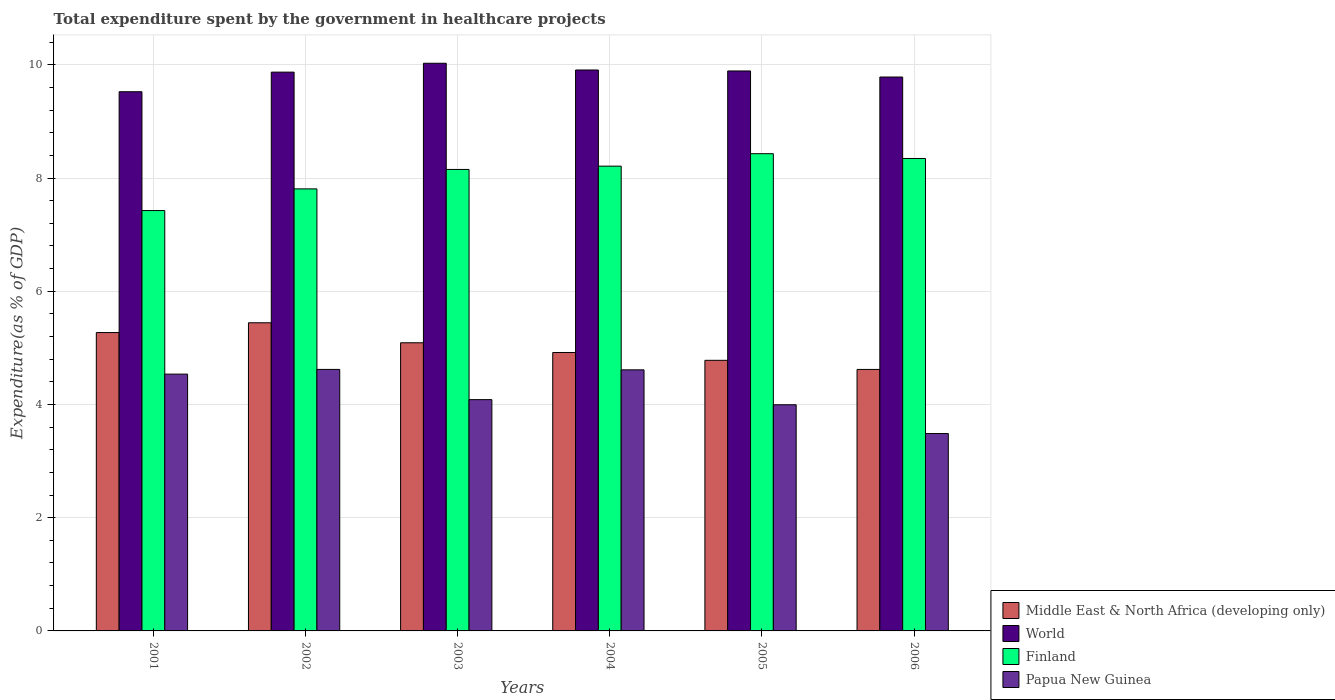How many different coloured bars are there?
Provide a succinct answer. 4. How many bars are there on the 6th tick from the left?
Offer a very short reply. 4. What is the label of the 2nd group of bars from the left?
Provide a succinct answer. 2002. In how many cases, is the number of bars for a given year not equal to the number of legend labels?
Provide a short and direct response. 0. What is the total expenditure spent by the government in healthcare projects in Middle East & North Africa (developing only) in 2006?
Provide a short and direct response. 4.62. Across all years, what is the maximum total expenditure spent by the government in healthcare projects in Finland?
Offer a very short reply. 8.43. Across all years, what is the minimum total expenditure spent by the government in healthcare projects in Papua New Guinea?
Your answer should be compact. 3.49. What is the total total expenditure spent by the government in healthcare projects in World in the graph?
Provide a short and direct response. 59. What is the difference between the total expenditure spent by the government in healthcare projects in Papua New Guinea in 2001 and that in 2003?
Your response must be concise. 0.45. What is the difference between the total expenditure spent by the government in healthcare projects in World in 2005 and the total expenditure spent by the government in healthcare projects in Papua New Guinea in 2006?
Provide a succinct answer. 6.4. What is the average total expenditure spent by the government in healthcare projects in Finland per year?
Provide a short and direct response. 8.06. In the year 2001, what is the difference between the total expenditure spent by the government in healthcare projects in Finland and total expenditure spent by the government in healthcare projects in World?
Offer a terse response. -2.1. What is the ratio of the total expenditure spent by the government in healthcare projects in Papua New Guinea in 2001 to that in 2006?
Ensure brevity in your answer.  1.3. What is the difference between the highest and the second highest total expenditure spent by the government in healthcare projects in World?
Provide a short and direct response. 0.12. What is the difference between the highest and the lowest total expenditure spent by the government in healthcare projects in World?
Provide a succinct answer. 0.5. Is the sum of the total expenditure spent by the government in healthcare projects in Papua New Guinea in 2002 and 2005 greater than the maximum total expenditure spent by the government in healthcare projects in World across all years?
Offer a terse response. No. Is it the case that in every year, the sum of the total expenditure spent by the government in healthcare projects in Middle East & North Africa (developing only) and total expenditure spent by the government in healthcare projects in Papua New Guinea is greater than the sum of total expenditure spent by the government in healthcare projects in Finland and total expenditure spent by the government in healthcare projects in World?
Provide a succinct answer. No. What does the 3rd bar from the left in 2006 represents?
Provide a succinct answer. Finland. What does the 3rd bar from the right in 2005 represents?
Provide a short and direct response. World. How many bars are there?
Offer a very short reply. 24. Are all the bars in the graph horizontal?
Offer a terse response. No. How many years are there in the graph?
Provide a succinct answer. 6. Does the graph contain any zero values?
Offer a very short reply. No. Where does the legend appear in the graph?
Your answer should be compact. Bottom right. How many legend labels are there?
Ensure brevity in your answer.  4. What is the title of the graph?
Give a very brief answer. Total expenditure spent by the government in healthcare projects. Does "Faeroe Islands" appear as one of the legend labels in the graph?
Offer a terse response. No. What is the label or title of the X-axis?
Your answer should be compact. Years. What is the label or title of the Y-axis?
Ensure brevity in your answer.  Expenditure(as % of GDP). What is the Expenditure(as % of GDP) of Middle East & North Africa (developing only) in 2001?
Offer a terse response. 5.27. What is the Expenditure(as % of GDP) in World in 2001?
Offer a very short reply. 9.52. What is the Expenditure(as % of GDP) of Finland in 2001?
Your response must be concise. 7.43. What is the Expenditure(as % of GDP) in Papua New Guinea in 2001?
Ensure brevity in your answer.  4.54. What is the Expenditure(as % of GDP) in Middle East & North Africa (developing only) in 2002?
Offer a very short reply. 5.44. What is the Expenditure(as % of GDP) of World in 2002?
Make the answer very short. 9.87. What is the Expenditure(as % of GDP) of Finland in 2002?
Offer a terse response. 7.81. What is the Expenditure(as % of GDP) of Papua New Guinea in 2002?
Provide a succinct answer. 4.62. What is the Expenditure(as % of GDP) in Middle East & North Africa (developing only) in 2003?
Your response must be concise. 5.09. What is the Expenditure(as % of GDP) of World in 2003?
Your answer should be very brief. 10.03. What is the Expenditure(as % of GDP) of Finland in 2003?
Provide a succinct answer. 8.15. What is the Expenditure(as % of GDP) in Papua New Guinea in 2003?
Offer a very short reply. 4.09. What is the Expenditure(as % of GDP) of Middle East & North Africa (developing only) in 2004?
Give a very brief answer. 4.92. What is the Expenditure(as % of GDP) in World in 2004?
Your answer should be very brief. 9.91. What is the Expenditure(as % of GDP) of Finland in 2004?
Your answer should be very brief. 8.21. What is the Expenditure(as % of GDP) in Papua New Guinea in 2004?
Your answer should be very brief. 4.61. What is the Expenditure(as % of GDP) of Middle East & North Africa (developing only) in 2005?
Provide a short and direct response. 4.78. What is the Expenditure(as % of GDP) of World in 2005?
Your answer should be compact. 9.89. What is the Expenditure(as % of GDP) of Finland in 2005?
Ensure brevity in your answer.  8.43. What is the Expenditure(as % of GDP) of Papua New Guinea in 2005?
Keep it short and to the point. 3.99. What is the Expenditure(as % of GDP) in Middle East & North Africa (developing only) in 2006?
Keep it short and to the point. 4.62. What is the Expenditure(as % of GDP) of World in 2006?
Give a very brief answer. 9.78. What is the Expenditure(as % of GDP) in Finland in 2006?
Ensure brevity in your answer.  8.34. What is the Expenditure(as % of GDP) in Papua New Guinea in 2006?
Offer a very short reply. 3.49. Across all years, what is the maximum Expenditure(as % of GDP) in Middle East & North Africa (developing only)?
Provide a short and direct response. 5.44. Across all years, what is the maximum Expenditure(as % of GDP) in World?
Your answer should be compact. 10.03. Across all years, what is the maximum Expenditure(as % of GDP) of Finland?
Keep it short and to the point. 8.43. Across all years, what is the maximum Expenditure(as % of GDP) in Papua New Guinea?
Make the answer very short. 4.62. Across all years, what is the minimum Expenditure(as % of GDP) of Middle East & North Africa (developing only)?
Your answer should be very brief. 4.62. Across all years, what is the minimum Expenditure(as % of GDP) in World?
Offer a very short reply. 9.52. Across all years, what is the minimum Expenditure(as % of GDP) of Finland?
Offer a terse response. 7.43. Across all years, what is the minimum Expenditure(as % of GDP) of Papua New Guinea?
Give a very brief answer. 3.49. What is the total Expenditure(as % of GDP) of Middle East & North Africa (developing only) in the graph?
Your answer should be compact. 30.12. What is the total Expenditure(as % of GDP) of World in the graph?
Make the answer very short. 59. What is the total Expenditure(as % of GDP) of Finland in the graph?
Give a very brief answer. 48.37. What is the total Expenditure(as % of GDP) of Papua New Guinea in the graph?
Ensure brevity in your answer.  25.33. What is the difference between the Expenditure(as % of GDP) in Middle East & North Africa (developing only) in 2001 and that in 2002?
Provide a succinct answer. -0.17. What is the difference between the Expenditure(as % of GDP) of World in 2001 and that in 2002?
Keep it short and to the point. -0.35. What is the difference between the Expenditure(as % of GDP) in Finland in 2001 and that in 2002?
Provide a short and direct response. -0.38. What is the difference between the Expenditure(as % of GDP) of Papua New Guinea in 2001 and that in 2002?
Make the answer very short. -0.08. What is the difference between the Expenditure(as % of GDP) in Middle East & North Africa (developing only) in 2001 and that in 2003?
Ensure brevity in your answer.  0.18. What is the difference between the Expenditure(as % of GDP) in World in 2001 and that in 2003?
Give a very brief answer. -0.5. What is the difference between the Expenditure(as % of GDP) of Finland in 2001 and that in 2003?
Keep it short and to the point. -0.73. What is the difference between the Expenditure(as % of GDP) of Papua New Guinea in 2001 and that in 2003?
Offer a terse response. 0.45. What is the difference between the Expenditure(as % of GDP) of Middle East & North Africa (developing only) in 2001 and that in 2004?
Make the answer very short. 0.35. What is the difference between the Expenditure(as % of GDP) in World in 2001 and that in 2004?
Your answer should be very brief. -0.38. What is the difference between the Expenditure(as % of GDP) of Finland in 2001 and that in 2004?
Give a very brief answer. -0.78. What is the difference between the Expenditure(as % of GDP) of Papua New Guinea in 2001 and that in 2004?
Your answer should be compact. -0.08. What is the difference between the Expenditure(as % of GDP) of Middle East & North Africa (developing only) in 2001 and that in 2005?
Make the answer very short. 0.49. What is the difference between the Expenditure(as % of GDP) in World in 2001 and that in 2005?
Keep it short and to the point. -0.37. What is the difference between the Expenditure(as % of GDP) of Finland in 2001 and that in 2005?
Offer a terse response. -1. What is the difference between the Expenditure(as % of GDP) of Papua New Guinea in 2001 and that in 2005?
Offer a very short reply. 0.54. What is the difference between the Expenditure(as % of GDP) in Middle East & North Africa (developing only) in 2001 and that in 2006?
Provide a short and direct response. 0.65. What is the difference between the Expenditure(as % of GDP) of World in 2001 and that in 2006?
Offer a very short reply. -0.26. What is the difference between the Expenditure(as % of GDP) in Finland in 2001 and that in 2006?
Give a very brief answer. -0.92. What is the difference between the Expenditure(as % of GDP) of Papua New Guinea in 2001 and that in 2006?
Keep it short and to the point. 1.05. What is the difference between the Expenditure(as % of GDP) of Middle East & North Africa (developing only) in 2002 and that in 2003?
Make the answer very short. 0.35. What is the difference between the Expenditure(as % of GDP) in World in 2002 and that in 2003?
Your response must be concise. -0.16. What is the difference between the Expenditure(as % of GDP) in Finland in 2002 and that in 2003?
Your answer should be very brief. -0.34. What is the difference between the Expenditure(as % of GDP) in Papua New Guinea in 2002 and that in 2003?
Provide a succinct answer. 0.53. What is the difference between the Expenditure(as % of GDP) in Middle East & North Africa (developing only) in 2002 and that in 2004?
Keep it short and to the point. 0.53. What is the difference between the Expenditure(as % of GDP) in World in 2002 and that in 2004?
Your answer should be very brief. -0.04. What is the difference between the Expenditure(as % of GDP) in Finland in 2002 and that in 2004?
Provide a succinct answer. -0.4. What is the difference between the Expenditure(as % of GDP) of Papua New Guinea in 2002 and that in 2004?
Your answer should be compact. 0.01. What is the difference between the Expenditure(as % of GDP) of Middle East & North Africa (developing only) in 2002 and that in 2005?
Give a very brief answer. 0.66. What is the difference between the Expenditure(as % of GDP) in World in 2002 and that in 2005?
Provide a succinct answer. -0.02. What is the difference between the Expenditure(as % of GDP) in Finland in 2002 and that in 2005?
Make the answer very short. -0.62. What is the difference between the Expenditure(as % of GDP) of Papua New Guinea in 2002 and that in 2005?
Keep it short and to the point. 0.62. What is the difference between the Expenditure(as % of GDP) of Middle East & North Africa (developing only) in 2002 and that in 2006?
Ensure brevity in your answer.  0.82. What is the difference between the Expenditure(as % of GDP) in World in 2002 and that in 2006?
Provide a succinct answer. 0.09. What is the difference between the Expenditure(as % of GDP) in Finland in 2002 and that in 2006?
Your response must be concise. -0.54. What is the difference between the Expenditure(as % of GDP) in Papua New Guinea in 2002 and that in 2006?
Provide a succinct answer. 1.13. What is the difference between the Expenditure(as % of GDP) in Middle East & North Africa (developing only) in 2003 and that in 2004?
Offer a very short reply. 0.17. What is the difference between the Expenditure(as % of GDP) of World in 2003 and that in 2004?
Ensure brevity in your answer.  0.12. What is the difference between the Expenditure(as % of GDP) of Finland in 2003 and that in 2004?
Give a very brief answer. -0.06. What is the difference between the Expenditure(as % of GDP) of Papua New Guinea in 2003 and that in 2004?
Make the answer very short. -0.53. What is the difference between the Expenditure(as % of GDP) in Middle East & North Africa (developing only) in 2003 and that in 2005?
Your response must be concise. 0.31. What is the difference between the Expenditure(as % of GDP) in World in 2003 and that in 2005?
Your answer should be very brief. 0.14. What is the difference between the Expenditure(as % of GDP) in Finland in 2003 and that in 2005?
Your answer should be very brief. -0.28. What is the difference between the Expenditure(as % of GDP) in Papua New Guinea in 2003 and that in 2005?
Your response must be concise. 0.09. What is the difference between the Expenditure(as % of GDP) of Middle East & North Africa (developing only) in 2003 and that in 2006?
Make the answer very short. 0.47. What is the difference between the Expenditure(as % of GDP) in World in 2003 and that in 2006?
Ensure brevity in your answer.  0.24. What is the difference between the Expenditure(as % of GDP) in Finland in 2003 and that in 2006?
Keep it short and to the point. -0.19. What is the difference between the Expenditure(as % of GDP) in Papua New Guinea in 2003 and that in 2006?
Provide a short and direct response. 0.6. What is the difference between the Expenditure(as % of GDP) in Middle East & North Africa (developing only) in 2004 and that in 2005?
Your answer should be very brief. 0.14. What is the difference between the Expenditure(as % of GDP) of World in 2004 and that in 2005?
Ensure brevity in your answer.  0.02. What is the difference between the Expenditure(as % of GDP) in Finland in 2004 and that in 2005?
Your answer should be compact. -0.22. What is the difference between the Expenditure(as % of GDP) of Papua New Guinea in 2004 and that in 2005?
Your answer should be compact. 0.62. What is the difference between the Expenditure(as % of GDP) in Middle East & North Africa (developing only) in 2004 and that in 2006?
Provide a succinct answer. 0.3. What is the difference between the Expenditure(as % of GDP) in World in 2004 and that in 2006?
Keep it short and to the point. 0.12. What is the difference between the Expenditure(as % of GDP) in Finland in 2004 and that in 2006?
Make the answer very short. -0.14. What is the difference between the Expenditure(as % of GDP) of Papua New Guinea in 2004 and that in 2006?
Offer a very short reply. 1.13. What is the difference between the Expenditure(as % of GDP) of Middle East & North Africa (developing only) in 2005 and that in 2006?
Offer a very short reply. 0.16. What is the difference between the Expenditure(as % of GDP) of World in 2005 and that in 2006?
Your answer should be very brief. 0.11. What is the difference between the Expenditure(as % of GDP) in Finland in 2005 and that in 2006?
Make the answer very short. 0.08. What is the difference between the Expenditure(as % of GDP) in Papua New Guinea in 2005 and that in 2006?
Offer a terse response. 0.51. What is the difference between the Expenditure(as % of GDP) of Middle East & North Africa (developing only) in 2001 and the Expenditure(as % of GDP) of World in 2002?
Offer a very short reply. -4.6. What is the difference between the Expenditure(as % of GDP) in Middle East & North Africa (developing only) in 2001 and the Expenditure(as % of GDP) in Finland in 2002?
Your response must be concise. -2.54. What is the difference between the Expenditure(as % of GDP) of Middle East & North Africa (developing only) in 2001 and the Expenditure(as % of GDP) of Papua New Guinea in 2002?
Provide a succinct answer. 0.65. What is the difference between the Expenditure(as % of GDP) of World in 2001 and the Expenditure(as % of GDP) of Finland in 2002?
Keep it short and to the point. 1.72. What is the difference between the Expenditure(as % of GDP) in World in 2001 and the Expenditure(as % of GDP) in Papua New Guinea in 2002?
Offer a very short reply. 4.9. What is the difference between the Expenditure(as % of GDP) in Finland in 2001 and the Expenditure(as % of GDP) in Papua New Guinea in 2002?
Your answer should be compact. 2.81. What is the difference between the Expenditure(as % of GDP) in Middle East & North Africa (developing only) in 2001 and the Expenditure(as % of GDP) in World in 2003?
Give a very brief answer. -4.76. What is the difference between the Expenditure(as % of GDP) in Middle East & North Africa (developing only) in 2001 and the Expenditure(as % of GDP) in Finland in 2003?
Keep it short and to the point. -2.88. What is the difference between the Expenditure(as % of GDP) of Middle East & North Africa (developing only) in 2001 and the Expenditure(as % of GDP) of Papua New Guinea in 2003?
Keep it short and to the point. 1.18. What is the difference between the Expenditure(as % of GDP) of World in 2001 and the Expenditure(as % of GDP) of Finland in 2003?
Offer a very short reply. 1.37. What is the difference between the Expenditure(as % of GDP) in World in 2001 and the Expenditure(as % of GDP) in Papua New Guinea in 2003?
Offer a very short reply. 5.44. What is the difference between the Expenditure(as % of GDP) of Finland in 2001 and the Expenditure(as % of GDP) of Papua New Guinea in 2003?
Offer a very short reply. 3.34. What is the difference between the Expenditure(as % of GDP) in Middle East & North Africa (developing only) in 2001 and the Expenditure(as % of GDP) in World in 2004?
Offer a terse response. -4.64. What is the difference between the Expenditure(as % of GDP) of Middle East & North Africa (developing only) in 2001 and the Expenditure(as % of GDP) of Finland in 2004?
Your answer should be very brief. -2.94. What is the difference between the Expenditure(as % of GDP) of Middle East & North Africa (developing only) in 2001 and the Expenditure(as % of GDP) of Papua New Guinea in 2004?
Your answer should be very brief. 0.66. What is the difference between the Expenditure(as % of GDP) of World in 2001 and the Expenditure(as % of GDP) of Finland in 2004?
Give a very brief answer. 1.31. What is the difference between the Expenditure(as % of GDP) in World in 2001 and the Expenditure(as % of GDP) in Papua New Guinea in 2004?
Keep it short and to the point. 4.91. What is the difference between the Expenditure(as % of GDP) in Finland in 2001 and the Expenditure(as % of GDP) in Papua New Guinea in 2004?
Offer a very short reply. 2.81. What is the difference between the Expenditure(as % of GDP) in Middle East & North Africa (developing only) in 2001 and the Expenditure(as % of GDP) in World in 2005?
Keep it short and to the point. -4.62. What is the difference between the Expenditure(as % of GDP) in Middle East & North Africa (developing only) in 2001 and the Expenditure(as % of GDP) in Finland in 2005?
Provide a short and direct response. -3.16. What is the difference between the Expenditure(as % of GDP) of Middle East & North Africa (developing only) in 2001 and the Expenditure(as % of GDP) of Papua New Guinea in 2005?
Ensure brevity in your answer.  1.28. What is the difference between the Expenditure(as % of GDP) of World in 2001 and the Expenditure(as % of GDP) of Finland in 2005?
Your answer should be compact. 1.09. What is the difference between the Expenditure(as % of GDP) in World in 2001 and the Expenditure(as % of GDP) in Papua New Guinea in 2005?
Provide a succinct answer. 5.53. What is the difference between the Expenditure(as % of GDP) of Finland in 2001 and the Expenditure(as % of GDP) of Papua New Guinea in 2005?
Make the answer very short. 3.43. What is the difference between the Expenditure(as % of GDP) of Middle East & North Africa (developing only) in 2001 and the Expenditure(as % of GDP) of World in 2006?
Provide a succinct answer. -4.51. What is the difference between the Expenditure(as % of GDP) of Middle East & North Africa (developing only) in 2001 and the Expenditure(as % of GDP) of Finland in 2006?
Ensure brevity in your answer.  -3.07. What is the difference between the Expenditure(as % of GDP) in Middle East & North Africa (developing only) in 2001 and the Expenditure(as % of GDP) in Papua New Guinea in 2006?
Provide a succinct answer. 1.78. What is the difference between the Expenditure(as % of GDP) of World in 2001 and the Expenditure(as % of GDP) of Finland in 2006?
Keep it short and to the point. 1.18. What is the difference between the Expenditure(as % of GDP) of World in 2001 and the Expenditure(as % of GDP) of Papua New Guinea in 2006?
Your response must be concise. 6.04. What is the difference between the Expenditure(as % of GDP) of Finland in 2001 and the Expenditure(as % of GDP) of Papua New Guinea in 2006?
Provide a succinct answer. 3.94. What is the difference between the Expenditure(as % of GDP) in Middle East & North Africa (developing only) in 2002 and the Expenditure(as % of GDP) in World in 2003?
Make the answer very short. -4.58. What is the difference between the Expenditure(as % of GDP) in Middle East & North Africa (developing only) in 2002 and the Expenditure(as % of GDP) in Finland in 2003?
Your answer should be very brief. -2.71. What is the difference between the Expenditure(as % of GDP) in Middle East & North Africa (developing only) in 2002 and the Expenditure(as % of GDP) in Papua New Guinea in 2003?
Provide a succinct answer. 1.36. What is the difference between the Expenditure(as % of GDP) in World in 2002 and the Expenditure(as % of GDP) in Finland in 2003?
Offer a very short reply. 1.72. What is the difference between the Expenditure(as % of GDP) of World in 2002 and the Expenditure(as % of GDP) of Papua New Guinea in 2003?
Give a very brief answer. 5.78. What is the difference between the Expenditure(as % of GDP) of Finland in 2002 and the Expenditure(as % of GDP) of Papua New Guinea in 2003?
Your answer should be very brief. 3.72. What is the difference between the Expenditure(as % of GDP) of Middle East & North Africa (developing only) in 2002 and the Expenditure(as % of GDP) of World in 2004?
Offer a terse response. -4.46. What is the difference between the Expenditure(as % of GDP) of Middle East & North Africa (developing only) in 2002 and the Expenditure(as % of GDP) of Finland in 2004?
Give a very brief answer. -2.77. What is the difference between the Expenditure(as % of GDP) of Middle East & North Africa (developing only) in 2002 and the Expenditure(as % of GDP) of Papua New Guinea in 2004?
Your response must be concise. 0.83. What is the difference between the Expenditure(as % of GDP) in World in 2002 and the Expenditure(as % of GDP) in Finland in 2004?
Offer a very short reply. 1.66. What is the difference between the Expenditure(as % of GDP) in World in 2002 and the Expenditure(as % of GDP) in Papua New Guinea in 2004?
Provide a succinct answer. 5.26. What is the difference between the Expenditure(as % of GDP) in Finland in 2002 and the Expenditure(as % of GDP) in Papua New Guinea in 2004?
Keep it short and to the point. 3.2. What is the difference between the Expenditure(as % of GDP) in Middle East & North Africa (developing only) in 2002 and the Expenditure(as % of GDP) in World in 2005?
Your response must be concise. -4.45. What is the difference between the Expenditure(as % of GDP) in Middle East & North Africa (developing only) in 2002 and the Expenditure(as % of GDP) in Finland in 2005?
Your response must be concise. -2.99. What is the difference between the Expenditure(as % of GDP) of Middle East & North Africa (developing only) in 2002 and the Expenditure(as % of GDP) of Papua New Guinea in 2005?
Provide a succinct answer. 1.45. What is the difference between the Expenditure(as % of GDP) of World in 2002 and the Expenditure(as % of GDP) of Finland in 2005?
Offer a very short reply. 1.44. What is the difference between the Expenditure(as % of GDP) of World in 2002 and the Expenditure(as % of GDP) of Papua New Guinea in 2005?
Offer a terse response. 5.88. What is the difference between the Expenditure(as % of GDP) in Finland in 2002 and the Expenditure(as % of GDP) in Papua New Guinea in 2005?
Offer a terse response. 3.81. What is the difference between the Expenditure(as % of GDP) of Middle East & North Africa (developing only) in 2002 and the Expenditure(as % of GDP) of World in 2006?
Your response must be concise. -4.34. What is the difference between the Expenditure(as % of GDP) of Middle East & North Africa (developing only) in 2002 and the Expenditure(as % of GDP) of Finland in 2006?
Your answer should be compact. -2.9. What is the difference between the Expenditure(as % of GDP) in Middle East & North Africa (developing only) in 2002 and the Expenditure(as % of GDP) in Papua New Guinea in 2006?
Make the answer very short. 1.96. What is the difference between the Expenditure(as % of GDP) of World in 2002 and the Expenditure(as % of GDP) of Finland in 2006?
Keep it short and to the point. 1.53. What is the difference between the Expenditure(as % of GDP) in World in 2002 and the Expenditure(as % of GDP) in Papua New Guinea in 2006?
Give a very brief answer. 6.38. What is the difference between the Expenditure(as % of GDP) of Finland in 2002 and the Expenditure(as % of GDP) of Papua New Guinea in 2006?
Your response must be concise. 4.32. What is the difference between the Expenditure(as % of GDP) of Middle East & North Africa (developing only) in 2003 and the Expenditure(as % of GDP) of World in 2004?
Your answer should be very brief. -4.82. What is the difference between the Expenditure(as % of GDP) of Middle East & North Africa (developing only) in 2003 and the Expenditure(as % of GDP) of Finland in 2004?
Offer a very short reply. -3.12. What is the difference between the Expenditure(as % of GDP) of Middle East & North Africa (developing only) in 2003 and the Expenditure(as % of GDP) of Papua New Guinea in 2004?
Offer a terse response. 0.48. What is the difference between the Expenditure(as % of GDP) in World in 2003 and the Expenditure(as % of GDP) in Finland in 2004?
Make the answer very short. 1.82. What is the difference between the Expenditure(as % of GDP) of World in 2003 and the Expenditure(as % of GDP) of Papua New Guinea in 2004?
Provide a short and direct response. 5.42. What is the difference between the Expenditure(as % of GDP) in Finland in 2003 and the Expenditure(as % of GDP) in Papua New Guinea in 2004?
Make the answer very short. 3.54. What is the difference between the Expenditure(as % of GDP) in Middle East & North Africa (developing only) in 2003 and the Expenditure(as % of GDP) in World in 2005?
Ensure brevity in your answer.  -4.8. What is the difference between the Expenditure(as % of GDP) in Middle East & North Africa (developing only) in 2003 and the Expenditure(as % of GDP) in Finland in 2005?
Provide a succinct answer. -3.34. What is the difference between the Expenditure(as % of GDP) of Middle East & North Africa (developing only) in 2003 and the Expenditure(as % of GDP) of Papua New Guinea in 2005?
Offer a very short reply. 1.09. What is the difference between the Expenditure(as % of GDP) in World in 2003 and the Expenditure(as % of GDP) in Finland in 2005?
Your response must be concise. 1.6. What is the difference between the Expenditure(as % of GDP) in World in 2003 and the Expenditure(as % of GDP) in Papua New Guinea in 2005?
Ensure brevity in your answer.  6.03. What is the difference between the Expenditure(as % of GDP) in Finland in 2003 and the Expenditure(as % of GDP) in Papua New Guinea in 2005?
Your answer should be very brief. 4.16. What is the difference between the Expenditure(as % of GDP) of Middle East & North Africa (developing only) in 2003 and the Expenditure(as % of GDP) of World in 2006?
Ensure brevity in your answer.  -4.69. What is the difference between the Expenditure(as % of GDP) of Middle East & North Africa (developing only) in 2003 and the Expenditure(as % of GDP) of Finland in 2006?
Give a very brief answer. -3.26. What is the difference between the Expenditure(as % of GDP) of Middle East & North Africa (developing only) in 2003 and the Expenditure(as % of GDP) of Papua New Guinea in 2006?
Provide a short and direct response. 1.6. What is the difference between the Expenditure(as % of GDP) in World in 2003 and the Expenditure(as % of GDP) in Finland in 2006?
Your response must be concise. 1.68. What is the difference between the Expenditure(as % of GDP) of World in 2003 and the Expenditure(as % of GDP) of Papua New Guinea in 2006?
Your response must be concise. 6.54. What is the difference between the Expenditure(as % of GDP) of Finland in 2003 and the Expenditure(as % of GDP) of Papua New Guinea in 2006?
Ensure brevity in your answer.  4.66. What is the difference between the Expenditure(as % of GDP) of Middle East & North Africa (developing only) in 2004 and the Expenditure(as % of GDP) of World in 2005?
Offer a very short reply. -4.97. What is the difference between the Expenditure(as % of GDP) of Middle East & North Africa (developing only) in 2004 and the Expenditure(as % of GDP) of Finland in 2005?
Keep it short and to the point. -3.51. What is the difference between the Expenditure(as % of GDP) in Middle East & North Africa (developing only) in 2004 and the Expenditure(as % of GDP) in Papua New Guinea in 2005?
Give a very brief answer. 0.92. What is the difference between the Expenditure(as % of GDP) in World in 2004 and the Expenditure(as % of GDP) in Finland in 2005?
Provide a short and direct response. 1.48. What is the difference between the Expenditure(as % of GDP) of World in 2004 and the Expenditure(as % of GDP) of Papua New Guinea in 2005?
Provide a short and direct response. 5.91. What is the difference between the Expenditure(as % of GDP) of Finland in 2004 and the Expenditure(as % of GDP) of Papua New Guinea in 2005?
Offer a very short reply. 4.21. What is the difference between the Expenditure(as % of GDP) in Middle East & North Africa (developing only) in 2004 and the Expenditure(as % of GDP) in World in 2006?
Offer a very short reply. -4.87. What is the difference between the Expenditure(as % of GDP) of Middle East & North Africa (developing only) in 2004 and the Expenditure(as % of GDP) of Finland in 2006?
Make the answer very short. -3.43. What is the difference between the Expenditure(as % of GDP) of Middle East & North Africa (developing only) in 2004 and the Expenditure(as % of GDP) of Papua New Guinea in 2006?
Offer a very short reply. 1.43. What is the difference between the Expenditure(as % of GDP) in World in 2004 and the Expenditure(as % of GDP) in Finland in 2006?
Offer a very short reply. 1.56. What is the difference between the Expenditure(as % of GDP) in World in 2004 and the Expenditure(as % of GDP) in Papua New Guinea in 2006?
Your answer should be very brief. 6.42. What is the difference between the Expenditure(as % of GDP) in Finland in 2004 and the Expenditure(as % of GDP) in Papua New Guinea in 2006?
Your answer should be very brief. 4.72. What is the difference between the Expenditure(as % of GDP) of Middle East & North Africa (developing only) in 2005 and the Expenditure(as % of GDP) of World in 2006?
Offer a terse response. -5. What is the difference between the Expenditure(as % of GDP) of Middle East & North Africa (developing only) in 2005 and the Expenditure(as % of GDP) of Finland in 2006?
Offer a very short reply. -3.57. What is the difference between the Expenditure(as % of GDP) of Middle East & North Africa (developing only) in 2005 and the Expenditure(as % of GDP) of Papua New Guinea in 2006?
Give a very brief answer. 1.29. What is the difference between the Expenditure(as % of GDP) in World in 2005 and the Expenditure(as % of GDP) in Finland in 2006?
Your answer should be very brief. 1.55. What is the difference between the Expenditure(as % of GDP) in World in 2005 and the Expenditure(as % of GDP) in Papua New Guinea in 2006?
Keep it short and to the point. 6.4. What is the difference between the Expenditure(as % of GDP) of Finland in 2005 and the Expenditure(as % of GDP) of Papua New Guinea in 2006?
Your answer should be very brief. 4.94. What is the average Expenditure(as % of GDP) of Middle East & North Africa (developing only) per year?
Offer a terse response. 5.02. What is the average Expenditure(as % of GDP) of World per year?
Ensure brevity in your answer.  9.83. What is the average Expenditure(as % of GDP) of Finland per year?
Your response must be concise. 8.06. What is the average Expenditure(as % of GDP) in Papua New Guinea per year?
Your answer should be compact. 4.22. In the year 2001, what is the difference between the Expenditure(as % of GDP) of Middle East & North Africa (developing only) and Expenditure(as % of GDP) of World?
Offer a very short reply. -4.25. In the year 2001, what is the difference between the Expenditure(as % of GDP) of Middle East & North Africa (developing only) and Expenditure(as % of GDP) of Finland?
Keep it short and to the point. -2.15. In the year 2001, what is the difference between the Expenditure(as % of GDP) of Middle East & North Africa (developing only) and Expenditure(as % of GDP) of Papua New Guinea?
Your response must be concise. 0.73. In the year 2001, what is the difference between the Expenditure(as % of GDP) in World and Expenditure(as % of GDP) in Finland?
Make the answer very short. 2.1. In the year 2001, what is the difference between the Expenditure(as % of GDP) in World and Expenditure(as % of GDP) in Papua New Guinea?
Provide a short and direct response. 4.99. In the year 2001, what is the difference between the Expenditure(as % of GDP) in Finland and Expenditure(as % of GDP) in Papua New Guinea?
Offer a terse response. 2.89. In the year 2002, what is the difference between the Expenditure(as % of GDP) in Middle East & North Africa (developing only) and Expenditure(as % of GDP) in World?
Provide a short and direct response. -4.43. In the year 2002, what is the difference between the Expenditure(as % of GDP) of Middle East & North Africa (developing only) and Expenditure(as % of GDP) of Finland?
Offer a terse response. -2.36. In the year 2002, what is the difference between the Expenditure(as % of GDP) in Middle East & North Africa (developing only) and Expenditure(as % of GDP) in Papua New Guinea?
Give a very brief answer. 0.82. In the year 2002, what is the difference between the Expenditure(as % of GDP) of World and Expenditure(as % of GDP) of Finland?
Provide a succinct answer. 2.06. In the year 2002, what is the difference between the Expenditure(as % of GDP) of World and Expenditure(as % of GDP) of Papua New Guinea?
Your response must be concise. 5.25. In the year 2002, what is the difference between the Expenditure(as % of GDP) in Finland and Expenditure(as % of GDP) in Papua New Guinea?
Your answer should be very brief. 3.19. In the year 2003, what is the difference between the Expenditure(as % of GDP) in Middle East & North Africa (developing only) and Expenditure(as % of GDP) in World?
Provide a short and direct response. -4.94. In the year 2003, what is the difference between the Expenditure(as % of GDP) of Middle East & North Africa (developing only) and Expenditure(as % of GDP) of Finland?
Ensure brevity in your answer.  -3.06. In the year 2003, what is the difference between the Expenditure(as % of GDP) of Middle East & North Africa (developing only) and Expenditure(as % of GDP) of Papua New Guinea?
Make the answer very short. 1. In the year 2003, what is the difference between the Expenditure(as % of GDP) in World and Expenditure(as % of GDP) in Finland?
Your answer should be very brief. 1.88. In the year 2003, what is the difference between the Expenditure(as % of GDP) in World and Expenditure(as % of GDP) in Papua New Guinea?
Your answer should be very brief. 5.94. In the year 2003, what is the difference between the Expenditure(as % of GDP) of Finland and Expenditure(as % of GDP) of Papua New Guinea?
Provide a short and direct response. 4.07. In the year 2004, what is the difference between the Expenditure(as % of GDP) of Middle East & North Africa (developing only) and Expenditure(as % of GDP) of World?
Your answer should be compact. -4.99. In the year 2004, what is the difference between the Expenditure(as % of GDP) in Middle East & North Africa (developing only) and Expenditure(as % of GDP) in Finland?
Give a very brief answer. -3.29. In the year 2004, what is the difference between the Expenditure(as % of GDP) in Middle East & North Africa (developing only) and Expenditure(as % of GDP) in Papua New Guinea?
Give a very brief answer. 0.31. In the year 2004, what is the difference between the Expenditure(as % of GDP) in World and Expenditure(as % of GDP) in Finland?
Keep it short and to the point. 1.7. In the year 2004, what is the difference between the Expenditure(as % of GDP) of World and Expenditure(as % of GDP) of Papua New Guinea?
Ensure brevity in your answer.  5.3. In the year 2004, what is the difference between the Expenditure(as % of GDP) of Finland and Expenditure(as % of GDP) of Papua New Guinea?
Ensure brevity in your answer.  3.6. In the year 2005, what is the difference between the Expenditure(as % of GDP) of Middle East & North Africa (developing only) and Expenditure(as % of GDP) of World?
Your answer should be very brief. -5.11. In the year 2005, what is the difference between the Expenditure(as % of GDP) of Middle East & North Africa (developing only) and Expenditure(as % of GDP) of Finland?
Keep it short and to the point. -3.65. In the year 2005, what is the difference between the Expenditure(as % of GDP) of Middle East & North Africa (developing only) and Expenditure(as % of GDP) of Papua New Guinea?
Your answer should be very brief. 0.78. In the year 2005, what is the difference between the Expenditure(as % of GDP) of World and Expenditure(as % of GDP) of Finland?
Provide a short and direct response. 1.46. In the year 2005, what is the difference between the Expenditure(as % of GDP) in World and Expenditure(as % of GDP) in Papua New Guinea?
Make the answer very short. 5.9. In the year 2005, what is the difference between the Expenditure(as % of GDP) of Finland and Expenditure(as % of GDP) of Papua New Guinea?
Keep it short and to the point. 4.43. In the year 2006, what is the difference between the Expenditure(as % of GDP) in Middle East & North Africa (developing only) and Expenditure(as % of GDP) in World?
Provide a short and direct response. -5.16. In the year 2006, what is the difference between the Expenditure(as % of GDP) in Middle East & North Africa (developing only) and Expenditure(as % of GDP) in Finland?
Keep it short and to the point. -3.73. In the year 2006, what is the difference between the Expenditure(as % of GDP) in Middle East & North Africa (developing only) and Expenditure(as % of GDP) in Papua New Guinea?
Offer a terse response. 1.13. In the year 2006, what is the difference between the Expenditure(as % of GDP) of World and Expenditure(as % of GDP) of Finland?
Provide a succinct answer. 1.44. In the year 2006, what is the difference between the Expenditure(as % of GDP) of World and Expenditure(as % of GDP) of Papua New Guinea?
Give a very brief answer. 6.3. In the year 2006, what is the difference between the Expenditure(as % of GDP) in Finland and Expenditure(as % of GDP) in Papua New Guinea?
Provide a short and direct response. 4.86. What is the ratio of the Expenditure(as % of GDP) of Middle East & North Africa (developing only) in 2001 to that in 2002?
Offer a very short reply. 0.97. What is the ratio of the Expenditure(as % of GDP) in World in 2001 to that in 2002?
Your answer should be very brief. 0.96. What is the ratio of the Expenditure(as % of GDP) in Finland in 2001 to that in 2002?
Offer a terse response. 0.95. What is the ratio of the Expenditure(as % of GDP) in Middle East & North Africa (developing only) in 2001 to that in 2003?
Offer a very short reply. 1.04. What is the ratio of the Expenditure(as % of GDP) of World in 2001 to that in 2003?
Ensure brevity in your answer.  0.95. What is the ratio of the Expenditure(as % of GDP) in Finland in 2001 to that in 2003?
Make the answer very short. 0.91. What is the ratio of the Expenditure(as % of GDP) of Papua New Guinea in 2001 to that in 2003?
Provide a succinct answer. 1.11. What is the ratio of the Expenditure(as % of GDP) of Middle East & North Africa (developing only) in 2001 to that in 2004?
Provide a short and direct response. 1.07. What is the ratio of the Expenditure(as % of GDP) in World in 2001 to that in 2004?
Ensure brevity in your answer.  0.96. What is the ratio of the Expenditure(as % of GDP) of Finland in 2001 to that in 2004?
Your response must be concise. 0.9. What is the ratio of the Expenditure(as % of GDP) of Papua New Guinea in 2001 to that in 2004?
Provide a succinct answer. 0.98. What is the ratio of the Expenditure(as % of GDP) of Middle East & North Africa (developing only) in 2001 to that in 2005?
Give a very brief answer. 1.1. What is the ratio of the Expenditure(as % of GDP) in World in 2001 to that in 2005?
Give a very brief answer. 0.96. What is the ratio of the Expenditure(as % of GDP) in Finland in 2001 to that in 2005?
Give a very brief answer. 0.88. What is the ratio of the Expenditure(as % of GDP) of Papua New Guinea in 2001 to that in 2005?
Make the answer very short. 1.14. What is the ratio of the Expenditure(as % of GDP) in Middle East & North Africa (developing only) in 2001 to that in 2006?
Offer a terse response. 1.14. What is the ratio of the Expenditure(as % of GDP) of World in 2001 to that in 2006?
Provide a succinct answer. 0.97. What is the ratio of the Expenditure(as % of GDP) of Finland in 2001 to that in 2006?
Provide a short and direct response. 0.89. What is the ratio of the Expenditure(as % of GDP) of Papua New Guinea in 2001 to that in 2006?
Your answer should be compact. 1.3. What is the ratio of the Expenditure(as % of GDP) of Middle East & North Africa (developing only) in 2002 to that in 2003?
Ensure brevity in your answer.  1.07. What is the ratio of the Expenditure(as % of GDP) of World in 2002 to that in 2003?
Your answer should be compact. 0.98. What is the ratio of the Expenditure(as % of GDP) of Finland in 2002 to that in 2003?
Provide a short and direct response. 0.96. What is the ratio of the Expenditure(as % of GDP) of Papua New Guinea in 2002 to that in 2003?
Keep it short and to the point. 1.13. What is the ratio of the Expenditure(as % of GDP) of Middle East & North Africa (developing only) in 2002 to that in 2004?
Offer a very short reply. 1.11. What is the ratio of the Expenditure(as % of GDP) in World in 2002 to that in 2004?
Your response must be concise. 1. What is the ratio of the Expenditure(as % of GDP) in Finland in 2002 to that in 2004?
Provide a succinct answer. 0.95. What is the ratio of the Expenditure(as % of GDP) of Middle East & North Africa (developing only) in 2002 to that in 2005?
Your answer should be very brief. 1.14. What is the ratio of the Expenditure(as % of GDP) of Finland in 2002 to that in 2005?
Ensure brevity in your answer.  0.93. What is the ratio of the Expenditure(as % of GDP) in Papua New Guinea in 2002 to that in 2005?
Give a very brief answer. 1.16. What is the ratio of the Expenditure(as % of GDP) of Middle East & North Africa (developing only) in 2002 to that in 2006?
Provide a succinct answer. 1.18. What is the ratio of the Expenditure(as % of GDP) in World in 2002 to that in 2006?
Your answer should be very brief. 1.01. What is the ratio of the Expenditure(as % of GDP) of Finland in 2002 to that in 2006?
Make the answer very short. 0.94. What is the ratio of the Expenditure(as % of GDP) in Papua New Guinea in 2002 to that in 2006?
Provide a succinct answer. 1.32. What is the ratio of the Expenditure(as % of GDP) of Middle East & North Africa (developing only) in 2003 to that in 2004?
Ensure brevity in your answer.  1.03. What is the ratio of the Expenditure(as % of GDP) of Papua New Guinea in 2003 to that in 2004?
Provide a short and direct response. 0.89. What is the ratio of the Expenditure(as % of GDP) in Middle East & North Africa (developing only) in 2003 to that in 2005?
Provide a short and direct response. 1.06. What is the ratio of the Expenditure(as % of GDP) of World in 2003 to that in 2005?
Make the answer very short. 1.01. What is the ratio of the Expenditure(as % of GDP) of Papua New Guinea in 2003 to that in 2005?
Make the answer very short. 1.02. What is the ratio of the Expenditure(as % of GDP) in Middle East & North Africa (developing only) in 2003 to that in 2006?
Your response must be concise. 1.1. What is the ratio of the Expenditure(as % of GDP) of World in 2003 to that in 2006?
Your answer should be compact. 1.02. What is the ratio of the Expenditure(as % of GDP) in Finland in 2003 to that in 2006?
Your answer should be compact. 0.98. What is the ratio of the Expenditure(as % of GDP) in Papua New Guinea in 2003 to that in 2006?
Offer a very short reply. 1.17. What is the ratio of the Expenditure(as % of GDP) of Middle East & North Africa (developing only) in 2004 to that in 2005?
Your response must be concise. 1.03. What is the ratio of the Expenditure(as % of GDP) of World in 2004 to that in 2005?
Give a very brief answer. 1. What is the ratio of the Expenditure(as % of GDP) in Finland in 2004 to that in 2005?
Your answer should be very brief. 0.97. What is the ratio of the Expenditure(as % of GDP) of Papua New Guinea in 2004 to that in 2005?
Keep it short and to the point. 1.15. What is the ratio of the Expenditure(as % of GDP) of Middle East & North Africa (developing only) in 2004 to that in 2006?
Offer a terse response. 1.06. What is the ratio of the Expenditure(as % of GDP) of World in 2004 to that in 2006?
Your response must be concise. 1.01. What is the ratio of the Expenditure(as % of GDP) of Finland in 2004 to that in 2006?
Offer a terse response. 0.98. What is the ratio of the Expenditure(as % of GDP) of Papua New Guinea in 2004 to that in 2006?
Your answer should be very brief. 1.32. What is the ratio of the Expenditure(as % of GDP) of Middle East & North Africa (developing only) in 2005 to that in 2006?
Make the answer very short. 1.03. What is the ratio of the Expenditure(as % of GDP) in World in 2005 to that in 2006?
Provide a short and direct response. 1.01. What is the ratio of the Expenditure(as % of GDP) of Finland in 2005 to that in 2006?
Ensure brevity in your answer.  1.01. What is the ratio of the Expenditure(as % of GDP) in Papua New Guinea in 2005 to that in 2006?
Offer a terse response. 1.15. What is the difference between the highest and the second highest Expenditure(as % of GDP) of Middle East & North Africa (developing only)?
Keep it short and to the point. 0.17. What is the difference between the highest and the second highest Expenditure(as % of GDP) in World?
Provide a succinct answer. 0.12. What is the difference between the highest and the second highest Expenditure(as % of GDP) in Finland?
Your answer should be very brief. 0.08. What is the difference between the highest and the second highest Expenditure(as % of GDP) in Papua New Guinea?
Your answer should be very brief. 0.01. What is the difference between the highest and the lowest Expenditure(as % of GDP) of Middle East & North Africa (developing only)?
Ensure brevity in your answer.  0.82. What is the difference between the highest and the lowest Expenditure(as % of GDP) of World?
Give a very brief answer. 0.5. What is the difference between the highest and the lowest Expenditure(as % of GDP) of Papua New Guinea?
Keep it short and to the point. 1.13. 